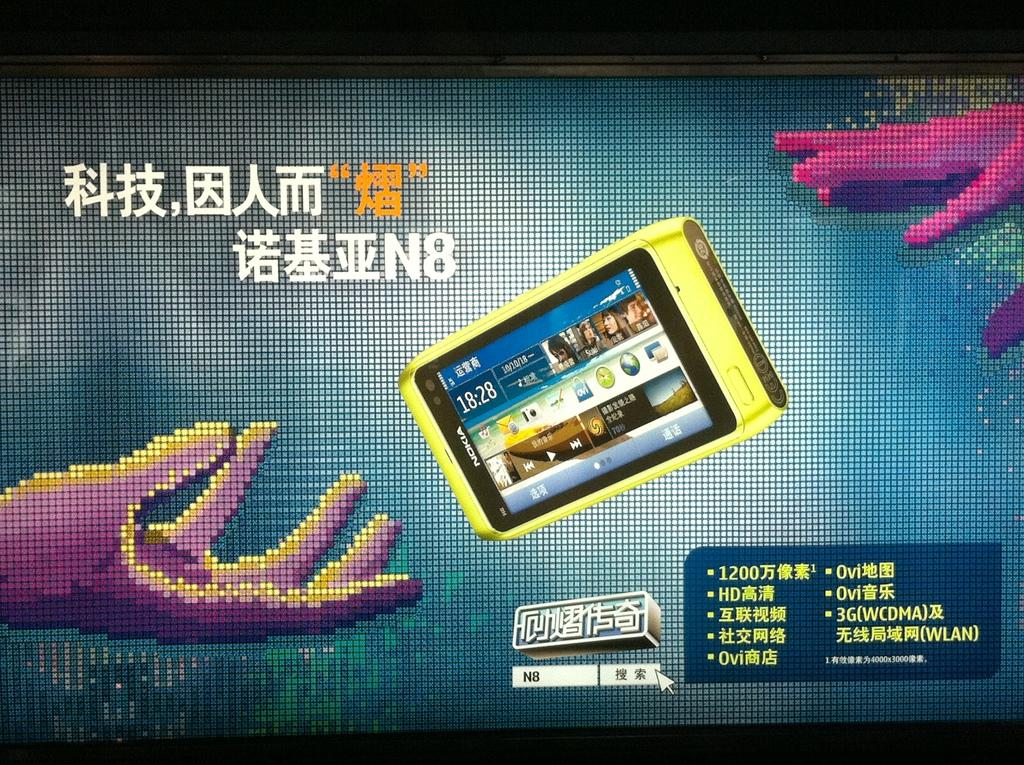<image>
Summarize the visual content of the image. A large screen with Chinese writing and two hands reaching for a cell phone that reads, 18:28. 